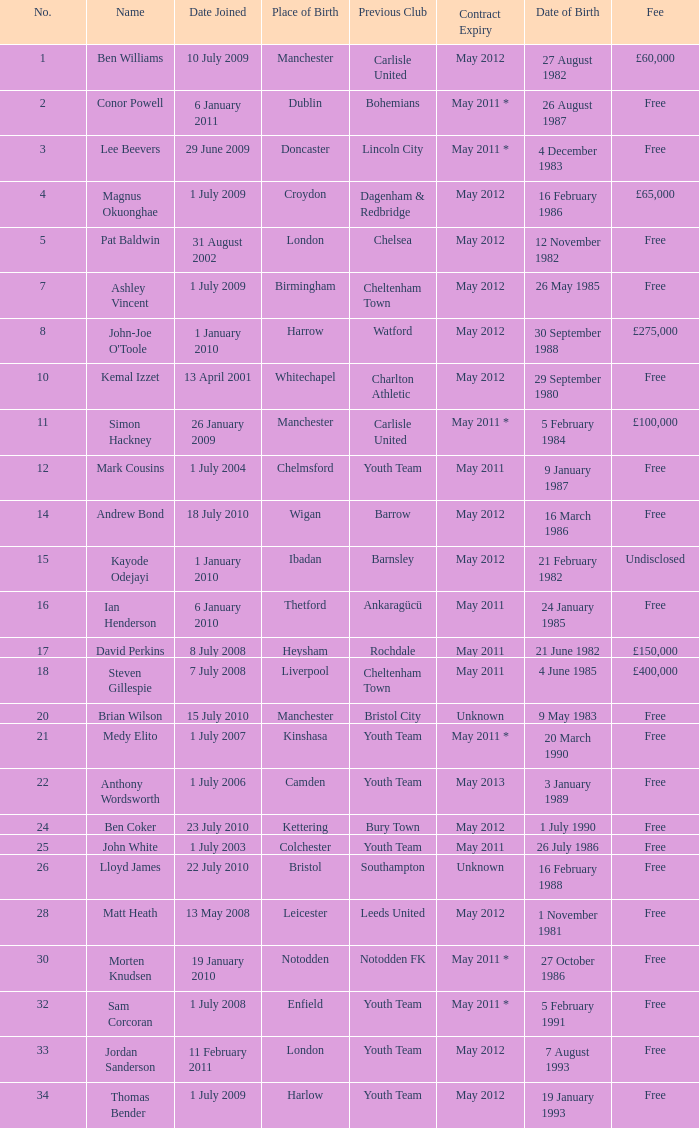What is the fee for ankaragücü previous club Free. Parse the full table. {'header': ['No.', 'Name', 'Date Joined', 'Place of Birth', 'Previous Club', 'Contract Expiry', 'Date of Birth', 'Fee'], 'rows': [['1', 'Ben Williams', '10 July 2009', 'Manchester', 'Carlisle United', 'May 2012', '27 August 1982', '£60,000'], ['2', 'Conor Powell', '6 January 2011', 'Dublin', 'Bohemians', 'May 2011 *', '26 August 1987', 'Free'], ['3', 'Lee Beevers', '29 June 2009', 'Doncaster', 'Lincoln City', 'May 2011 *', '4 December 1983', 'Free'], ['4', 'Magnus Okuonghae', '1 July 2009', 'Croydon', 'Dagenham & Redbridge', 'May 2012', '16 February 1986', '£65,000'], ['5', 'Pat Baldwin', '31 August 2002', 'London', 'Chelsea', 'May 2012', '12 November 1982', 'Free'], ['7', 'Ashley Vincent', '1 July 2009', 'Birmingham', 'Cheltenham Town', 'May 2012', '26 May 1985', 'Free'], ['8', "John-Joe O'Toole", '1 January 2010', 'Harrow', 'Watford', 'May 2012', '30 September 1988', '£275,000'], ['10', 'Kemal Izzet', '13 April 2001', 'Whitechapel', 'Charlton Athletic', 'May 2012', '29 September 1980', 'Free'], ['11', 'Simon Hackney', '26 January 2009', 'Manchester', 'Carlisle United', 'May 2011 *', '5 February 1984', '£100,000'], ['12', 'Mark Cousins', '1 July 2004', 'Chelmsford', 'Youth Team', 'May 2011', '9 January 1987', 'Free'], ['14', 'Andrew Bond', '18 July 2010', 'Wigan', 'Barrow', 'May 2012', '16 March 1986', 'Free'], ['15', 'Kayode Odejayi', '1 January 2010', 'Ibadan', 'Barnsley', 'May 2012', '21 February 1982', 'Undisclosed'], ['16', 'Ian Henderson', '6 January 2010', 'Thetford', 'Ankaragücü', 'May 2011', '24 January 1985', 'Free'], ['17', 'David Perkins', '8 July 2008', 'Heysham', 'Rochdale', 'May 2011', '21 June 1982', '£150,000'], ['18', 'Steven Gillespie', '7 July 2008', 'Liverpool', 'Cheltenham Town', 'May 2011', '4 June 1985', '£400,000'], ['20', 'Brian Wilson', '15 July 2010', 'Manchester', 'Bristol City', 'Unknown', '9 May 1983', 'Free'], ['21', 'Medy Elito', '1 July 2007', 'Kinshasa', 'Youth Team', 'May 2011 *', '20 March 1990', 'Free'], ['22', 'Anthony Wordsworth', '1 July 2006', 'Camden', 'Youth Team', 'May 2013', '3 January 1989', 'Free'], ['24', 'Ben Coker', '23 July 2010', 'Kettering', 'Bury Town', 'May 2012', '1 July 1990', 'Free'], ['25', 'John White', '1 July 2003', 'Colchester', 'Youth Team', 'May 2011', '26 July 1986', 'Free'], ['26', 'Lloyd James', '22 July 2010', 'Bristol', 'Southampton', 'Unknown', '16 February 1988', 'Free'], ['28', 'Matt Heath', '13 May 2008', 'Leicester', 'Leeds United', 'May 2012', '1 November 1981', 'Free'], ['30', 'Morten Knudsen', '19 January 2010', 'Notodden', 'Notodden FK', 'May 2011 *', '27 October 1986', 'Free'], ['32', 'Sam Corcoran', '1 July 2008', 'Enfield', 'Youth Team', 'May 2011 *', '5 February 1991', 'Free'], ['33', 'Jordan Sanderson', '11 February 2011', 'London', 'Youth Team', 'May 2012', '7 August 1993', 'Free'], ['34', 'Thomas Bender', '1 July 2009', 'Harlow', 'Youth Team', 'May 2012', '19 January 1993', 'Free']]} 